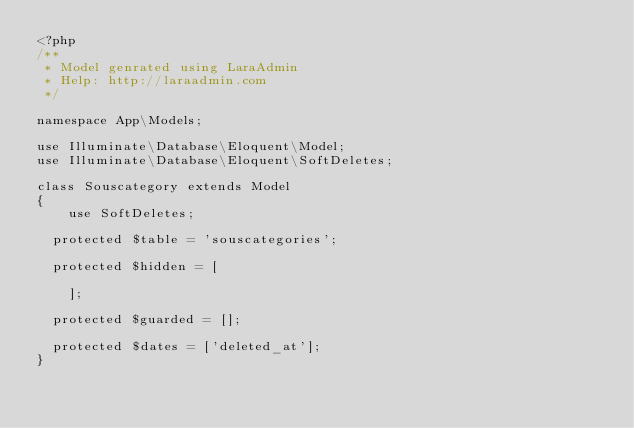Convert code to text. <code><loc_0><loc_0><loc_500><loc_500><_PHP_><?php
/**
 * Model genrated using LaraAdmin
 * Help: http://laraadmin.com
 */

namespace App\Models;

use Illuminate\Database\Eloquent\Model;
use Illuminate\Database\Eloquent\SoftDeletes;

class Souscategory extends Model
{
    use SoftDeletes;
	
	protected $table = 'souscategories';
	
	protected $hidden = [
        
    ];

	protected $guarded = [];

	protected $dates = ['deleted_at'];
}
</code> 